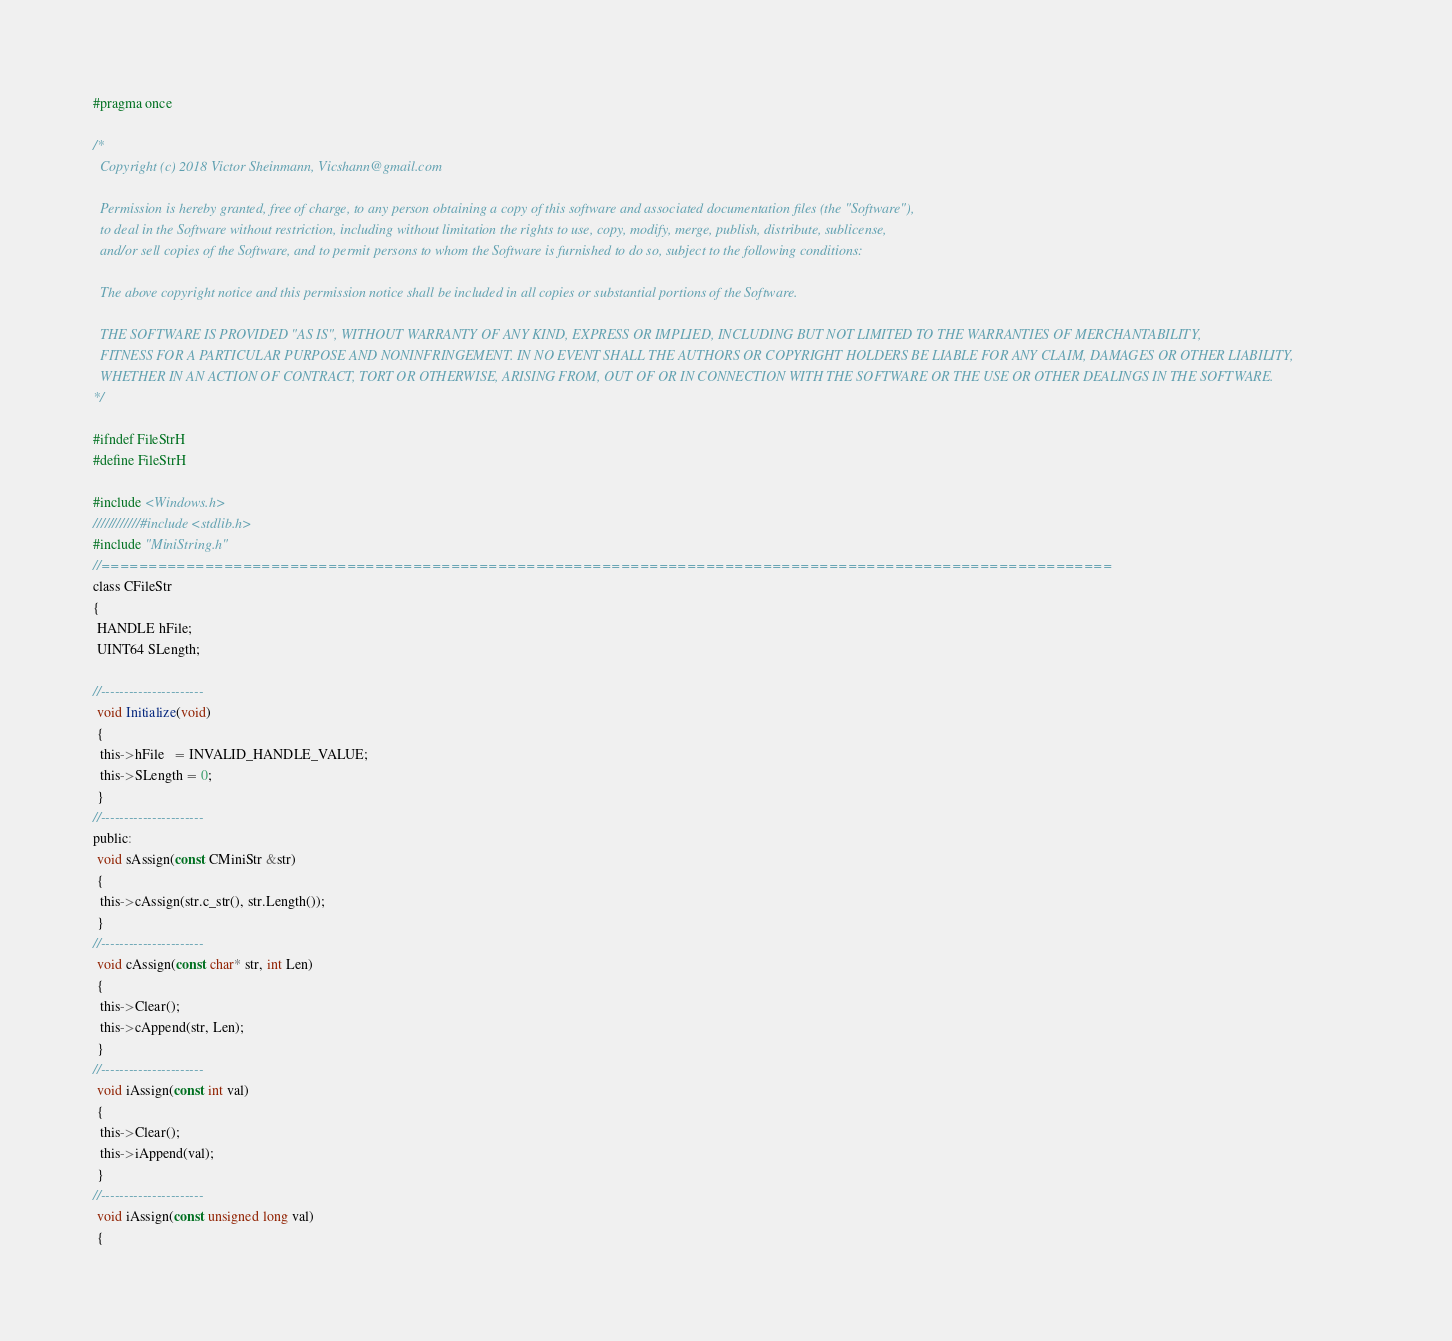<code> <loc_0><loc_0><loc_500><loc_500><_C_>
#pragma once

/*
  Copyright (c) 2018 Victor Sheinmann, Vicshann@gmail.com

  Permission is hereby granted, free of charge, to any person obtaining a copy of this software and associated documentation files (the "Software"), 
  to deal in the Software without restriction, including without limitation the rights to use, copy, modify, merge, publish, distribute, sublicense, 
  and/or sell copies of the Software, and to permit persons to whom the Software is furnished to do so, subject to the following conditions:

  The above copyright notice and this permission notice shall be included in all copies or substantial portions of the Software.

  THE SOFTWARE IS PROVIDED "AS IS", WITHOUT WARRANTY OF ANY KIND, EXPRESS OR IMPLIED, INCLUDING BUT NOT LIMITED TO THE WARRANTIES OF MERCHANTABILITY, 
  FITNESS FOR A PARTICULAR PURPOSE AND NONINFRINGEMENT. IN NO EVENT SHALL THE AUTHORS OR COPYRIGHT HOLDERS BE LIABLE FOR ANY CLAIM, DAMAGES OR OTHER LIABILITY, 
  WHETHER IN AN ACTION OF CONTRACT, TORT OR OTHERWISE, ARISING FROM, OUT OF OR IN CONNECTION WITH THE SOFTWARE OR THE USE OR OTHER DEALINGS IN THE SOFTWARE. 
*/

#ifndef FileStrH
#define FileStrH

#include <Windows.h>
////////////#include <stdlib.h>
#include "MiniString.h"
//===========================================================================================================
class CFileStr
{
 HANDLE hFile;
 UINT64 SLength;

//----------------------
 void Initialize(void)
 {
  this->hFile   = INVALID_HANDLE_VALUE;
  this->SLength = 0;
 }
//----------------------
public:
 void sAssign(const CMiniStr &str)
 {
  this->cAssign(str.c_str(), str.Length());
 }
//----------------------
 void cAssign(const char* str, int Len)
 {
  this->Clear();
  this->cAppend(str, Len);
 }
//----------------------
 void iAssign(const int val)
 {
  this->Clear();
  this->iAppend(val);
 }
//----------------------
 void iAssign(const unsigned long val)
 {</code> 